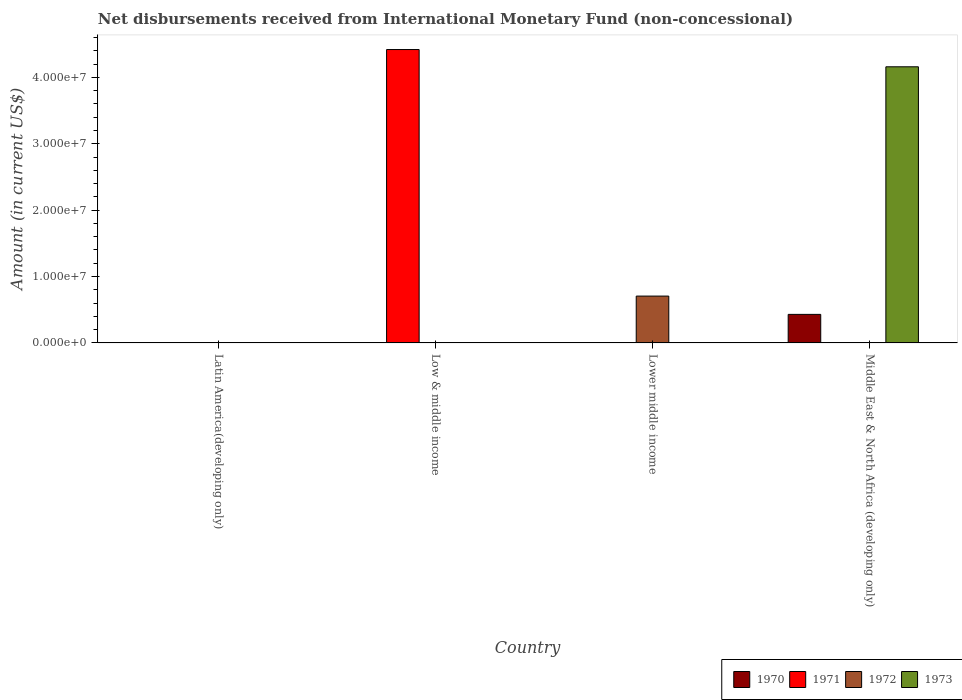How many different coloured bars are there?
Give a very brief answer. 4. Are the number of bars per tick equal to the number of legend labels?
Give a very brief answer. No. How many bars are there on the 1st tick from the left?
Give a very brief answer. 0. Across all countries, what is the maximum amount of disbursements received from International Monetary Fund in 1973?
Keep it short and to the point. 4.16e+07. Across all countries, what is the minimum amount of disbursements received from International Monetary Fund in 1972?
Your answer should be compact. 0. In which country was the amount of disbursements received from International Monetary Fund in 1973 maximum?
Offer a very short reply. Middle East & North Africa (developing only). What is the total amount of disbursements received from International Monetary Fund in 1972 in the graph?
Ensure brevity in your answer.  7.06e+06. What is the difference between the amount of disbursements received from International Monetary Fund in 1973 in Low & middle income and the amount of disbursements received from International Monetary Fund in 1970 in Middle East & North Africa (developing only)?
Your response must be concise. -4.30e+06. What is the average amount of disbursements received from International Monetary Fund in 1971 per country?
Your answer should be very brief. 1.10e+07. What is the difference between the amount of disbursements received from International Monetary Fund of/in 1973 and amount of disbursements received from International Monetary Fund of/in 1970 in Middle East & North Africa (developing only)?
Offer a very short reply. 3.73e+07. What is the difference between the highest and the lowest amount of disbursements received from International Monetary Fund in 1971?
Provide a short and direct response. 4.42e+07. In how many countries, is the amount of disbursements received from International Monetary Fund in 1973 greater than the average amount of disbursements received from International Monetary Fund in 1973 taken over all countries?
Provide a succinct answer. 1. Is it the case that in every country, the sum of the amount of disbursements received from International Monetary Fund in 1971 and amount of disbursements received from International Monetary Fund in 1972 is greater than the sum of amount of disbursements received from International Monetary Fund in 1973 and amount of disbursements received from International Monetary Fund in 1970?
Keep it short and to the point. No. Is it the case that in every country, the sum of the amount of disbursements received from International Monetary Fund in 1971 and amount of disbursements received from International Monetary Fund in 1972 is greater than the amount of disbursements received from International Monetary Fund in 1970?
Give a very brief answer. No. How many bars are there?
Provide a short and direct response. 4. Does the graph contain any zero values?
Your response must be concise. Yes. Does the graph contain grids?
Your answer should be compact. No. Where does the legend appear in the graph?
Offer a terse response. Bottom right. What is the title of the graph?
Keep it short and to the point. Net disbursements received from International Monetary Fund (non-concessional). Does "1991" appear as one of the legend labels in the graph?
Ensure brevity in your answer.  No. What is the label or title of the X-axis?
Offer a terse response. Country. What is the Amount (in current US$) of 1970 in Low & middle income?
Provide a short and direct response. 0. What is the Amount (in current US$) in 1971 in Low & middle income?
Make the answer very short. 4.42e+07. What is the Amount (in current US$) of 1972 in Low & middle income?
Your answer should be compact. 0. What is the Amount (in current US$) in 1973 in Low & middle income?
Offer a terse response. 0. What is the Amount (in current US$) of 1971 in Lower middle income?
Offer a very short reply. 0. What is the Amount (in current US$) of 1972 in Lower middle income?
Your answer should be very brief. 7.06e+06. What is the Amount (in current US$) in 1973 in Lower middle income?
Give a very brief answer. 0. What is the Amount (in current US$) in 1970 in Middle East & North Africa (developing only)?
Provide a succinct answer. 4.30e+06. What is the Amount (in current US$) in 1971 in Middle East & North Africa (developing only)?
Your response must be concise. 0. What is the Amount (in current US$) in 1972 in Middle East & North Africa (developing only)?
Your answer should be very brief. 0. What is the Amount (in current US$) in 1973 in Middle East & North Africa (developing only)?
Make the answer very short. 4.16e+07. Across all countries, what is the maximum Amount (in current US$) in 1970?
Keep it short and to the point. 4.30e+06. Across all countries, what is the maximum Amount (in current US$) in 1971?
Provide a short and direct response. 4.42e+07. Across all countries, what is the maximum Amount (in current US$) in 1972?
Keep it short and to the point. 7.06e+06. Across all countries, what is the maximum Amount (in current US$) of 1973?
Your answer should be very brief. 4.16e+07. Across all countries, what is the minimum Amount (in current US$) in 1970?
Keep it short and to the point. 0. Across all countries, what is the minimum Amount (in current US$) of 1971?
Provide a short and direct response. 0. What is the total Amount (in current US$) in 1970 in the graph?
Provide a short and direct response. 4.30e+06. What is the total Amount (in current US$) of 1971 in the graph?
Your answer should be very brief. 4.42e+07. What is the total Amount (in current US$) of 1972 in the graph?
Make the answer very short. 7.06e+06. What is the total Amount (in current US$) in 1973 in the graph?
Give a very brief answer. 4.16e+07. What is the difference between the Amount (in current US$) in 1971 in Low & middle income and the Amount (in current US$) in 1972 in Lower middle income?
Ensure brevity in your answer.  3.71e+07. What is the difference between the Amount (in current US$) of 1971 in Low & middle income and the Amount (in current US$) of 1973 in Middle East & North Africa (developing only)?
Your answer should be compact. 2.60e+06. What is the difference between the Amount (in current US$) of 1972 in Lower middle income and the Amount (in current US$) of 1973 in Middle East & North Africa (developing only)?
Make the answer very short. -3.45e+07. What is the average Amount (in current US$) of 1970 per country?
Offer a terse response. 1.08e+06. What is the average Amount (in current US$) of 1971 per country?
Your answer should be compact. 1.10e+07. What is the average Amount (in current US$) in 1972 per country?
Give a very brief answer. 1.76e+06. What is the average Amount (in current US$) of 1973 per country?
Keep it short and to the point. 1.04e+07. What is the difference between the Amount (in current US$) in 1970 and Amount (in current US$) in 1973 in Middle East & North Africa (developing only)?
Offer a very short reply. -3.73e+07. What is the difference between the highest and the lowest Amount (in current US$) of 1970?
Make the answer very short. 4.30e+06. What is the difference between the highest and the lowest Amount (in current US$) of 1971?
Provide a short and direct response. 4.42e+07. What is the difference between the highest and the lowest Amount (in current US$) in 1972?
Your response must be concise. 7.06e+06. What is the difference between the highest and the lowest Amount (in current US$) in 1973?
Keep it short and to the point. 4.16e+07. 